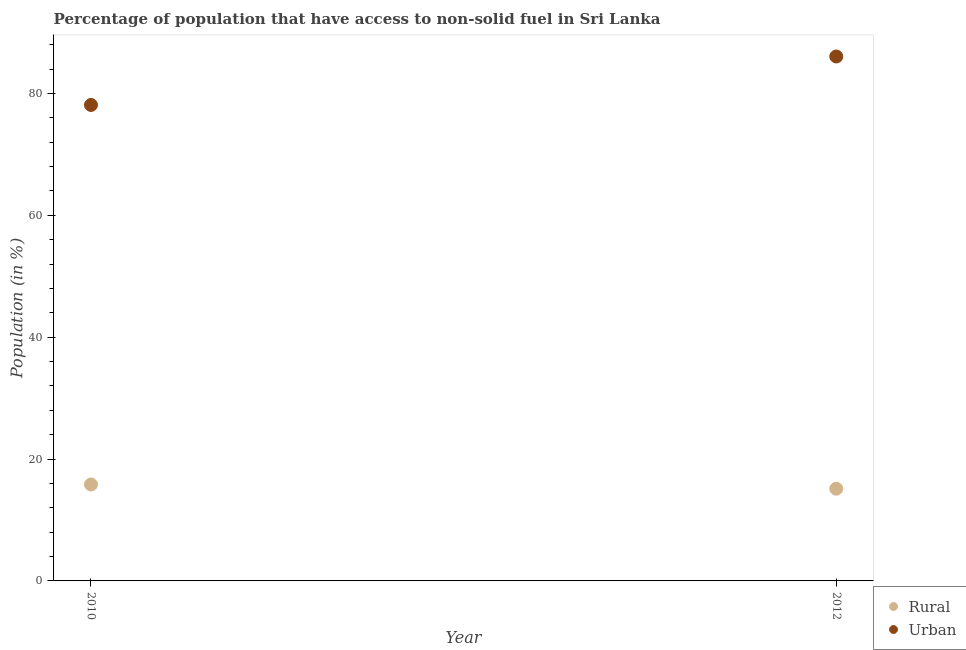Is the number of dotlines equal to the number of legend labels?
Keep it short and to the point. Yes. What is the rural population in 2012?
Make the answer very short. 15.14. Across all years, what is the maximum urban population?
Your response must be concise. 86.08. Across all years, what is the minimum rural population?
Offer a very short reply. 15.14. What is the total urban population in the graph?
Ensure brevity in your answer.  164.2. What is the difference between the rural population in 2010 and that in 2012?
Your response must be concise. 0.69. What is the difference between the urban population in 2010 and the rural population in 2012?
Your answer should be compact. 62.99. What is the average rural population per year?
Keep it short and to the point. 15.48. In the year 2012, what is the difference between the urban population and rural population?
Offer a very short reply. 70.94. In how many years, is the rural population greater than 80 %?
Keep it short and to the point. 0. What is the ratio of the rural population in 2010 to that in 2012?
Offer a very short reply. 1.05. Is the rural population in 2010 less than that in 2012?
Your response must be concise. No. How many dotlines are there?
Your answer should be very brief. 2. What is the difference between two consecutive major ticks on the Y-axis?
Make the answer very short. 20. How many legend labels are there?
Ensure brevity in your answer.  2. What is the title of the graph?
Provide a succinct answer. Percentage of population that have access to non-solid fuel in Sri Lanka. Does "Secondary school" appear as one of the legend labels in the graph?
Offer a very short reply. No. What is the Population (in %) in Rural in 2010?
Give a very brief answer. 15.83. What is the Population (in %) in Urban in 2010?
Keep it short and to the point. 78.12. What is the Population (in %) in Rural in 2012?
Your answer should be very brief. 15.14. What is the Population (in %) in Urban in 2012?
Offer a terse response. 86.08. Across all years, what is the maximum Population (in %) of Rural?
Ensure brevity in your answer.  15.83. Across all years, what is the maximum Population (in %) of Urban?
Provide a short and direct response. 86.08. Across all years, what is the minimum Population (in %) of Rural?
Offer a terse response. 15.14. Across all years, what is the minimum Population (in %) in Urban?
Ensure brevity in your answer.  78.12. What is the total Population (in %) in Rural in the graph?
Make the answer very short. 30.97. What is the total Population (in %) of Urban in the graph?
Provide a succinct answer. 164.2. What is the difference between the Population (in %) in Rural in 2010 and that in 2012?
Keep it short and to the point. 0.69. What is the difference between the Population (in %) in Urban in 2010 and that in 2012?
Ensure brevity in your answer.  -7.95. What is the difference between the Population (in %) in Rural in 2010 and the Population (in %) in Urban in 2012?
Make the answer very short. -70.25. What is the average Population (in %) of Rural per year?
Make the answer very short. 15.48. What is the average Population (in %) in Urban per year?
Give a very brief answer. 82.1. In the year 2010, what is the difference between the Population (in %) of Rural and Population (in %) of Urban?
Offer a terse response. -62.29. In the year 2012, what is the difference between the Population (in %) of Rural and Population (in %) of Urban?
Keep it short and to the point. -70.94. What is the ratio of the Population (in %) of Rural in 2010 to that in 2012?
Provide a short and direct response. 1.05. What is the ratio of the Population (in %) in Urban in 2010 to that in 2012?
Keep it short and to the point. 0.91. What is the difference between the highest and the second highest Population (in %) of Rural?
Offer a very short reply. 0.69. What is the difference between the highest and the second highest Population (in %) of Urban?
Your answer should be compact. 7.95. What is the difference between the highest and the lowest Population (in %) of Rural?
Ensure brevity in your answer.  0.69. What is the difference between the highest and the lowest Population (in %) of Urban?
Make the answer very short. 7.95. 